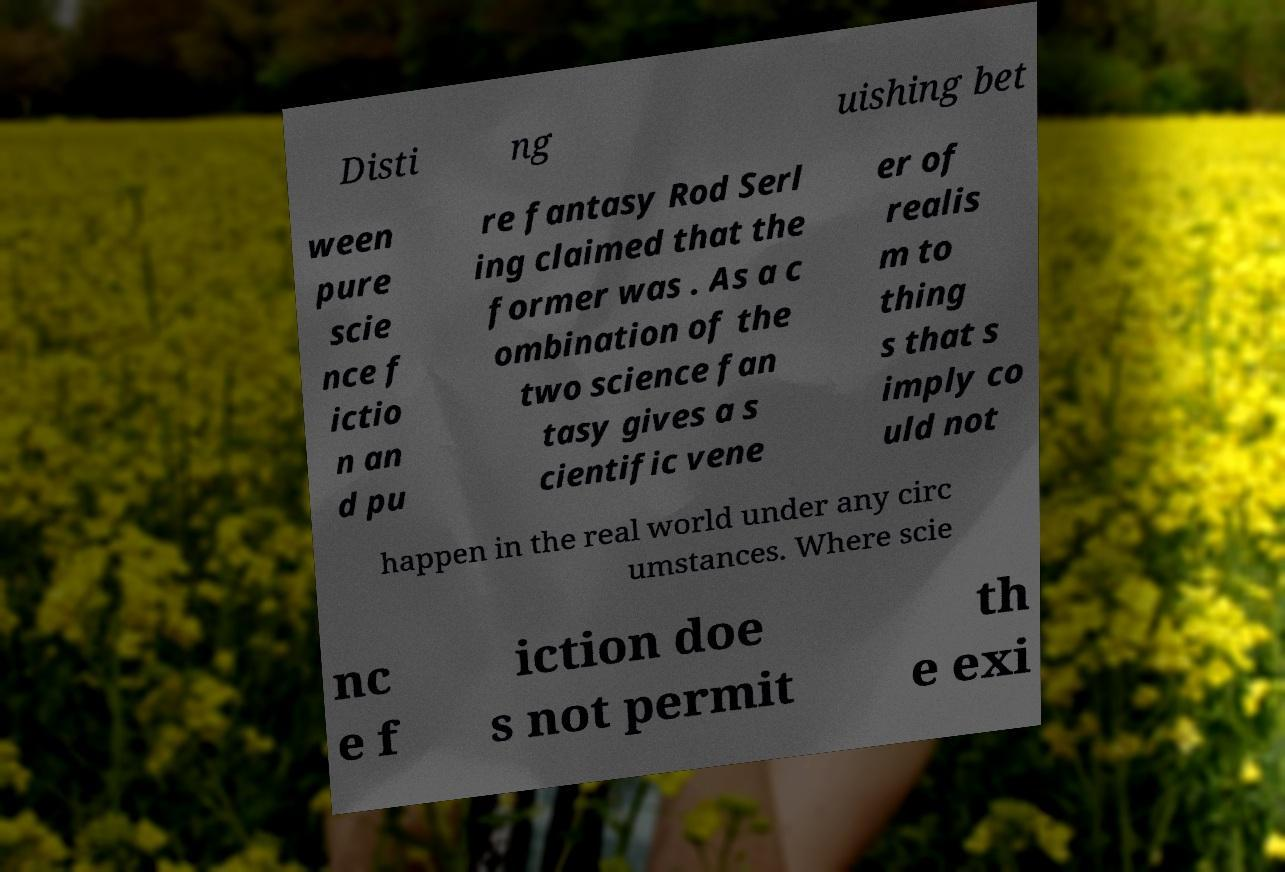Please read and relay the text visible in this image. What does it say? Disti ng uishing bet ween pure scie nce f ictio n an d pu re fantasy Rod Serl ing claimed that the former was . As a c ombination of the two science fan tasy gives a s cientific vene er of realis m to thing s that s imply co uld not happen in the real world under any circ umstances. Where scie nc e f iction doe s not permit th e exi 